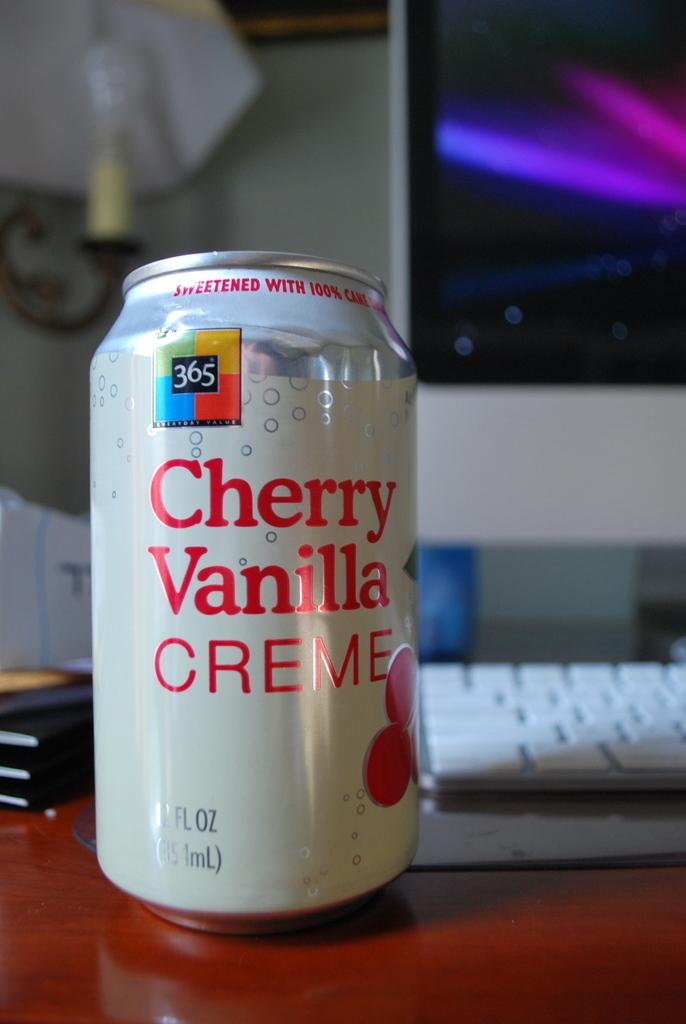<image>
Provide a brief description of the given image. Cheery Vanilla Creme soda next to a Mac desktop. 